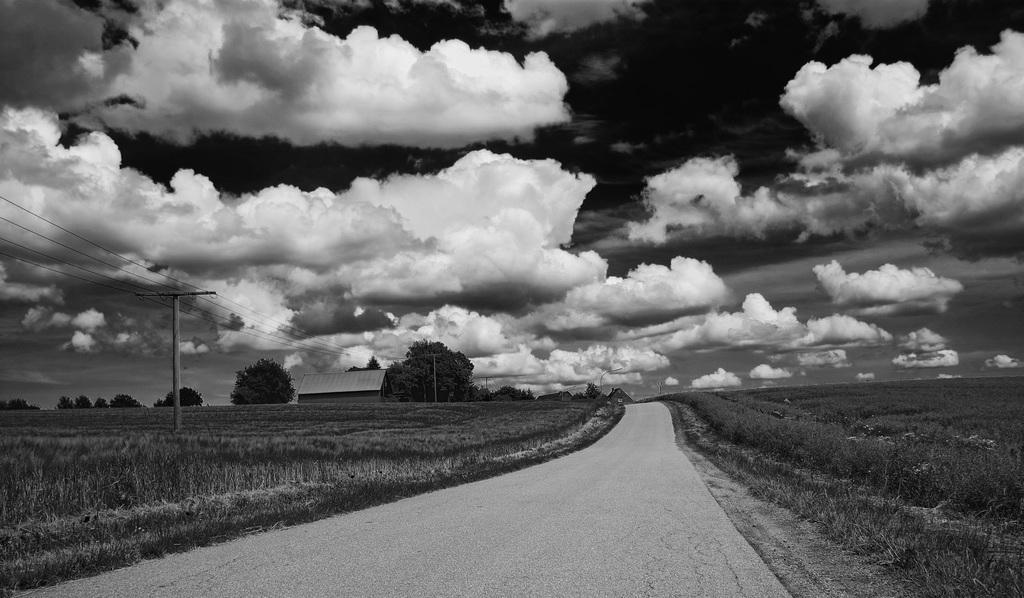Please provide a concise description of this image. In this image there are some plants, and at the bottom there is a walkway and on the left side of the image there are trees, house, poles, wires. And in the background there are trees, at the top there is sky. 